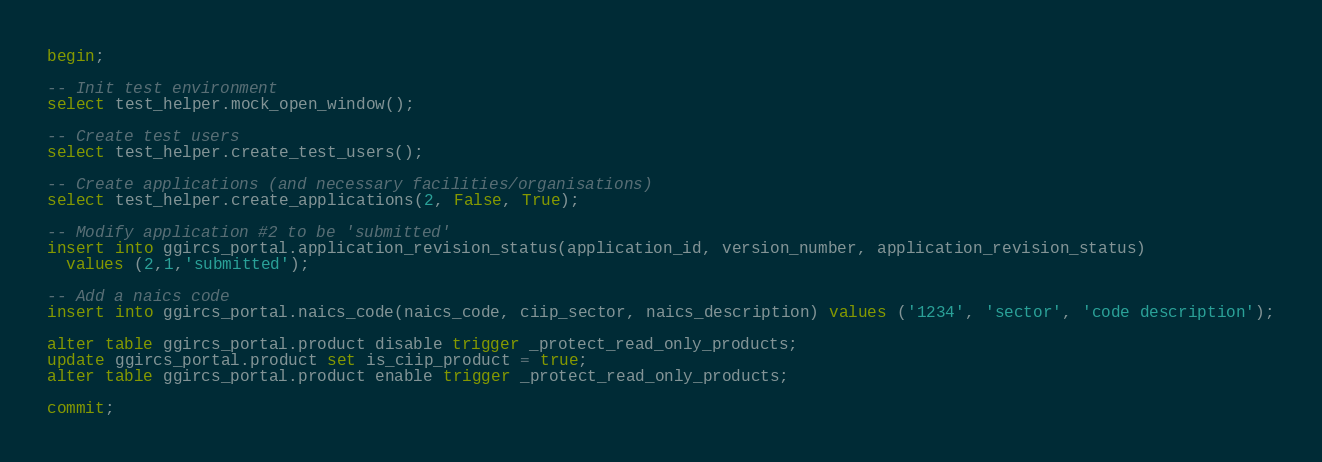Convert code to text. <code><loc_0><loc_0><loc_500><loc_500><_SQL_>begin;

-- Init test environment
select test_helper.mock_open_window();

-- Create test users
select test_helper.create_test_users();

-- Create applications (and necessary facilities/organisations)
select test_helper.create_applications(2, False, True);

-- Modify application #2 to be 'submitted'
insert into ggircs_portal.application_revision_status(application_id, version_number, application_revision_status)
  values (2,1,'submitted');

-- Add a naics code
insert into ggircs_portal.naics_code(naics_code, ciip_sector, naics_description) values ('1234', 'sector', 'code description');

alter table ggircs_portal.product disable trigger _protect_read_only_products;
update ggircs_portal.product set is_ciip_product = true;
alter table ggircs_portal.product enable trigger _protect_read_only_products;

commit;
</code> 